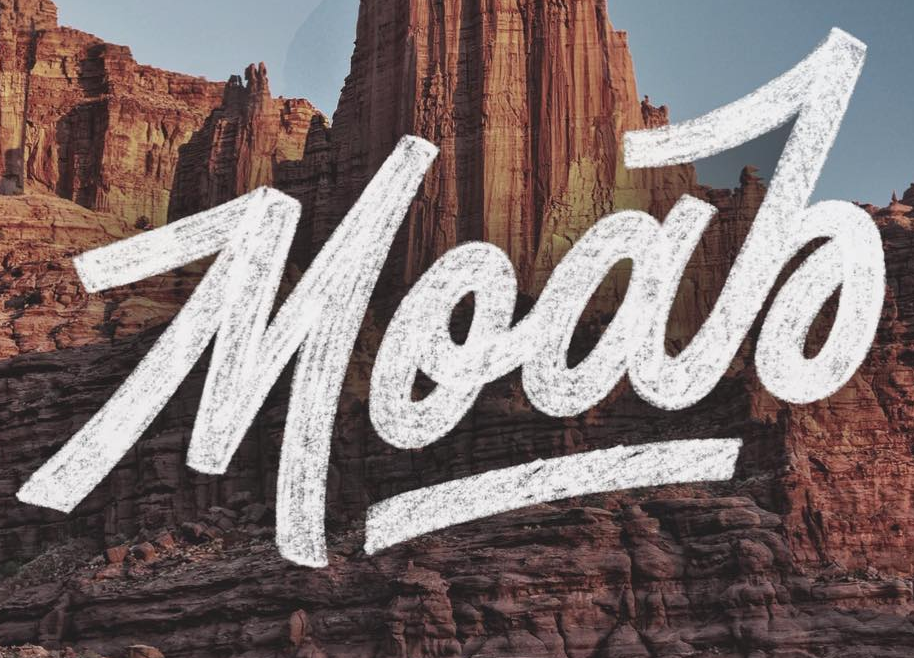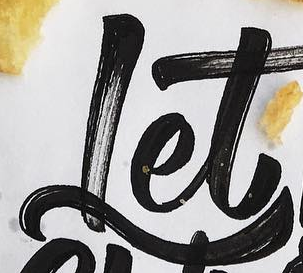What words can you see in these images in sequence, separated by a semicolon? MooJo; Let 